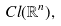Convert formula to latex. <formula><loc_0><loc_0><loc_500><loc_500>C l ( \mathbb { R } ^ { n } ) ,</formula> 